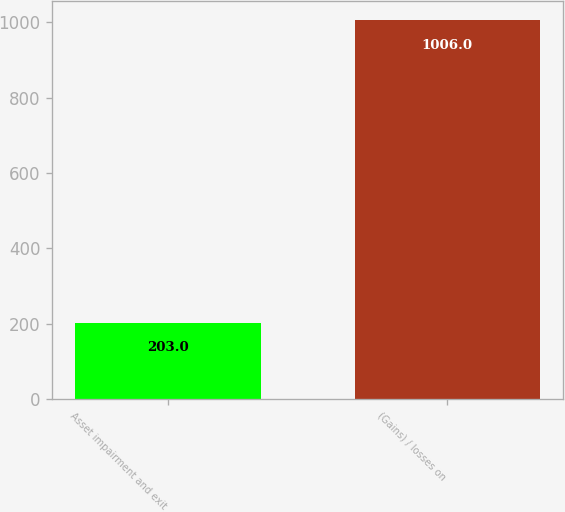<chart> <loc_0><loc_0><loc_500><loc_500><bar_chart><fcel>Asset impairment and exit<fcel>(Gains) / losses on<nl><fcel>203<fcel>1006<nl></chart> 